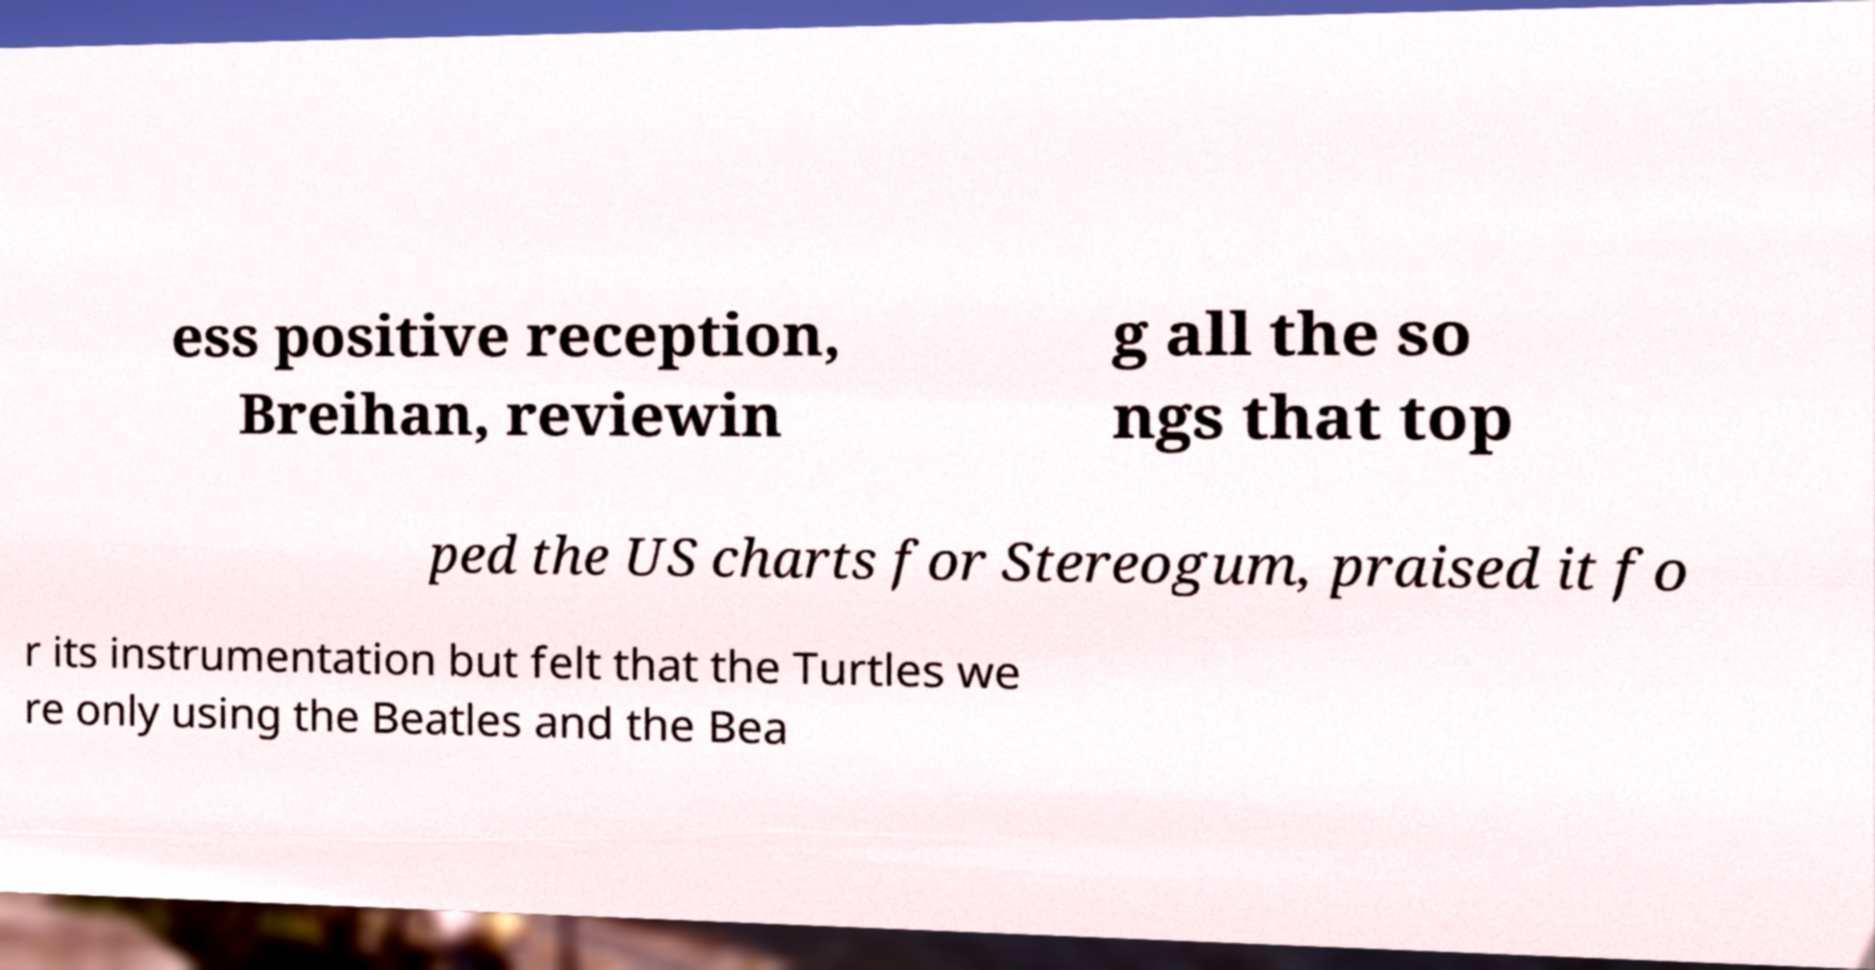I need the written content from this picture converted into text. Can you do that? ess positive reception, Breihan, reviewin g all the so ngs that top ped the US charts for Stereogum, praised it fo r its instrumentation but felt that the Turtles we re only using the Beatles and the Bea 